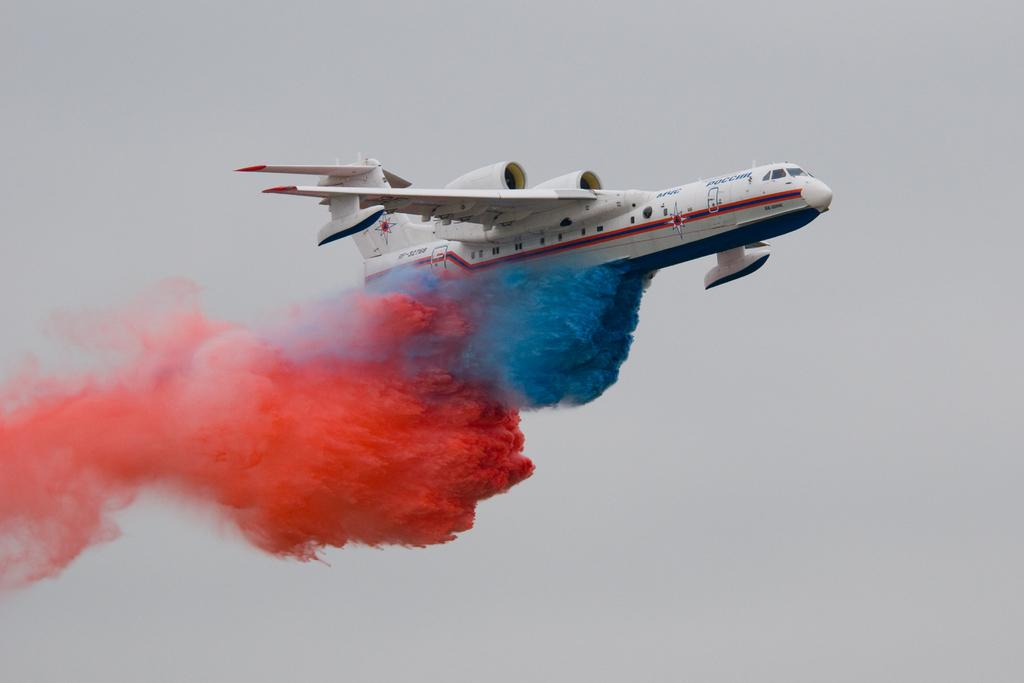What is the main subject in the middle of the image? There is a plane in the middle of the image. What can be observed in the air around the plane? Colors are present in the air. What is visible in the background of the image? There is sky visible in the background of the image. How many quince are hanging from the plane in the image? There are no quince present in the image, as quince is a type of fruit and not related to planes or the sky. 